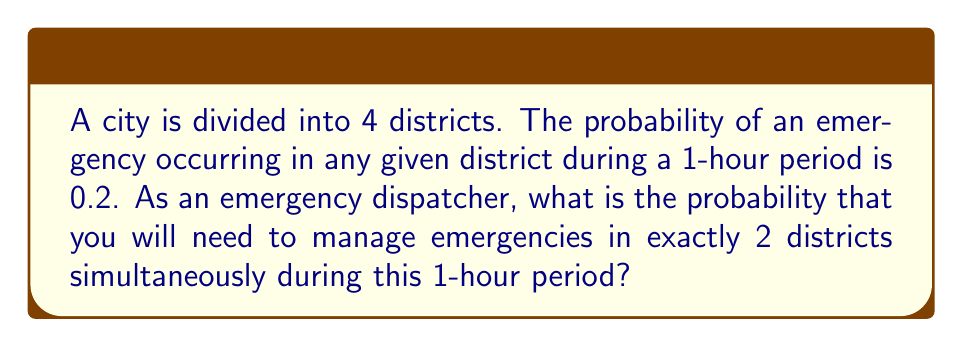Show me your answer to this math problem. To solve this problem, we'll use the binomial probability formula:

$$ P(X = k) = \binom{n}{k} p^k (1-p)^{n-k} $$

Where:
$n$ = number of trials (districts) = 4
$k$ = number of successes (districts with emergencies) = 2
$p$ = probability of success (emergency occurring) = 0.2

Step 1: Calculate the binomial coefficient $\binom{n}{k}$
$$ \binom{4}{2} = \frac{4!}{2!(4-2)!} = \frac{4 \cdot 3}{2 \cdot 1} = 6 $$

Step 2: Calculate $p^k$
$$ 0.2^2 = 0.04 $$

Step 3: Calculate $(1-p)^{n-k}$
$$ (1-0.2)^{4-2} = 0.8^2 = 0.64 $$

Step 4: Multiply all parts together
$$ 6 \cdot 0.04 \cdot 0.64 = 0.1536 $$

Therefore, the probability of exactly 2 districts having emergencies simultaneously is 0.1536 or 15.36%.
Answer: 0.1536 